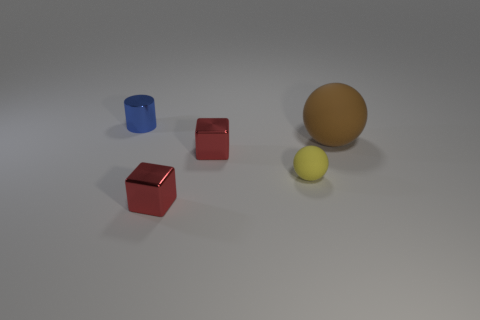What color is the other small ball that is made of the same material as the brown sphere?
Ensure brevity in your answer.  Yellow. How many cubes are the same size as the blue shiny cylinder?
Your response must be concise. 2. What is the yellow ball made of?
Your response must be concise. Rubber. Is the number of large red rubber blocks greater than the number of red objects?
Your response must be concise. No. Is the yellow thing the same shape as the brown object?
Offer a very short reply. Yes. Is there anything else that is the same shape as the blue metal thing?
Your answer should be compact. No. Is the color of the rubber thing in front of the large brown sphere the same as the ball that is behind the small yellow ball?
Keep it short and to the point. No. Are there fewer big brown rubber spheres to the left of the brown object than red things that are to the left of the small blue shiny cylinder?
Provide a succinct answer. No. The object that is behind the brown matte ball has what shape?
Offer a very short reply. Cylinder. What number of other objects are the same material as the yellow ball?
Provide a succinct answer. 1. 